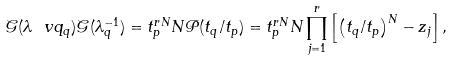<formula> <loc_0><loc_0><loc_500><loc_500>\mathcal { G } ( \lambda \ v q _ { q } ) \mathcal { G } ( \lambda _ { q } ^ { - 1 } ) = t _ { p } ^ { r N } N \mathcal { P } ( t _ { q } / t _ { p } ) = t _ { p } ^ { r N } N \prod _ { j = 1 } ^ { r } \left [ \left ( { { t _ { q } } / { t _ { p } } } \right ) ^ { N } - z _ { j } \right ] ,</formula> 